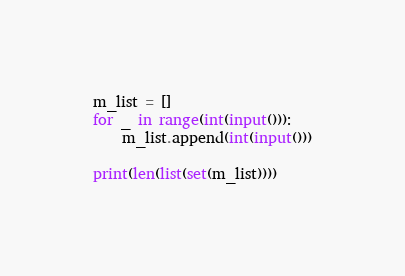<code> <loc_0><loc_0><loc_500><loc_500><_Python_>m_list = []
for _ in range(int(input())):
    m_list.append(int(input()))

print(len(list(set(m_list))))</code> 